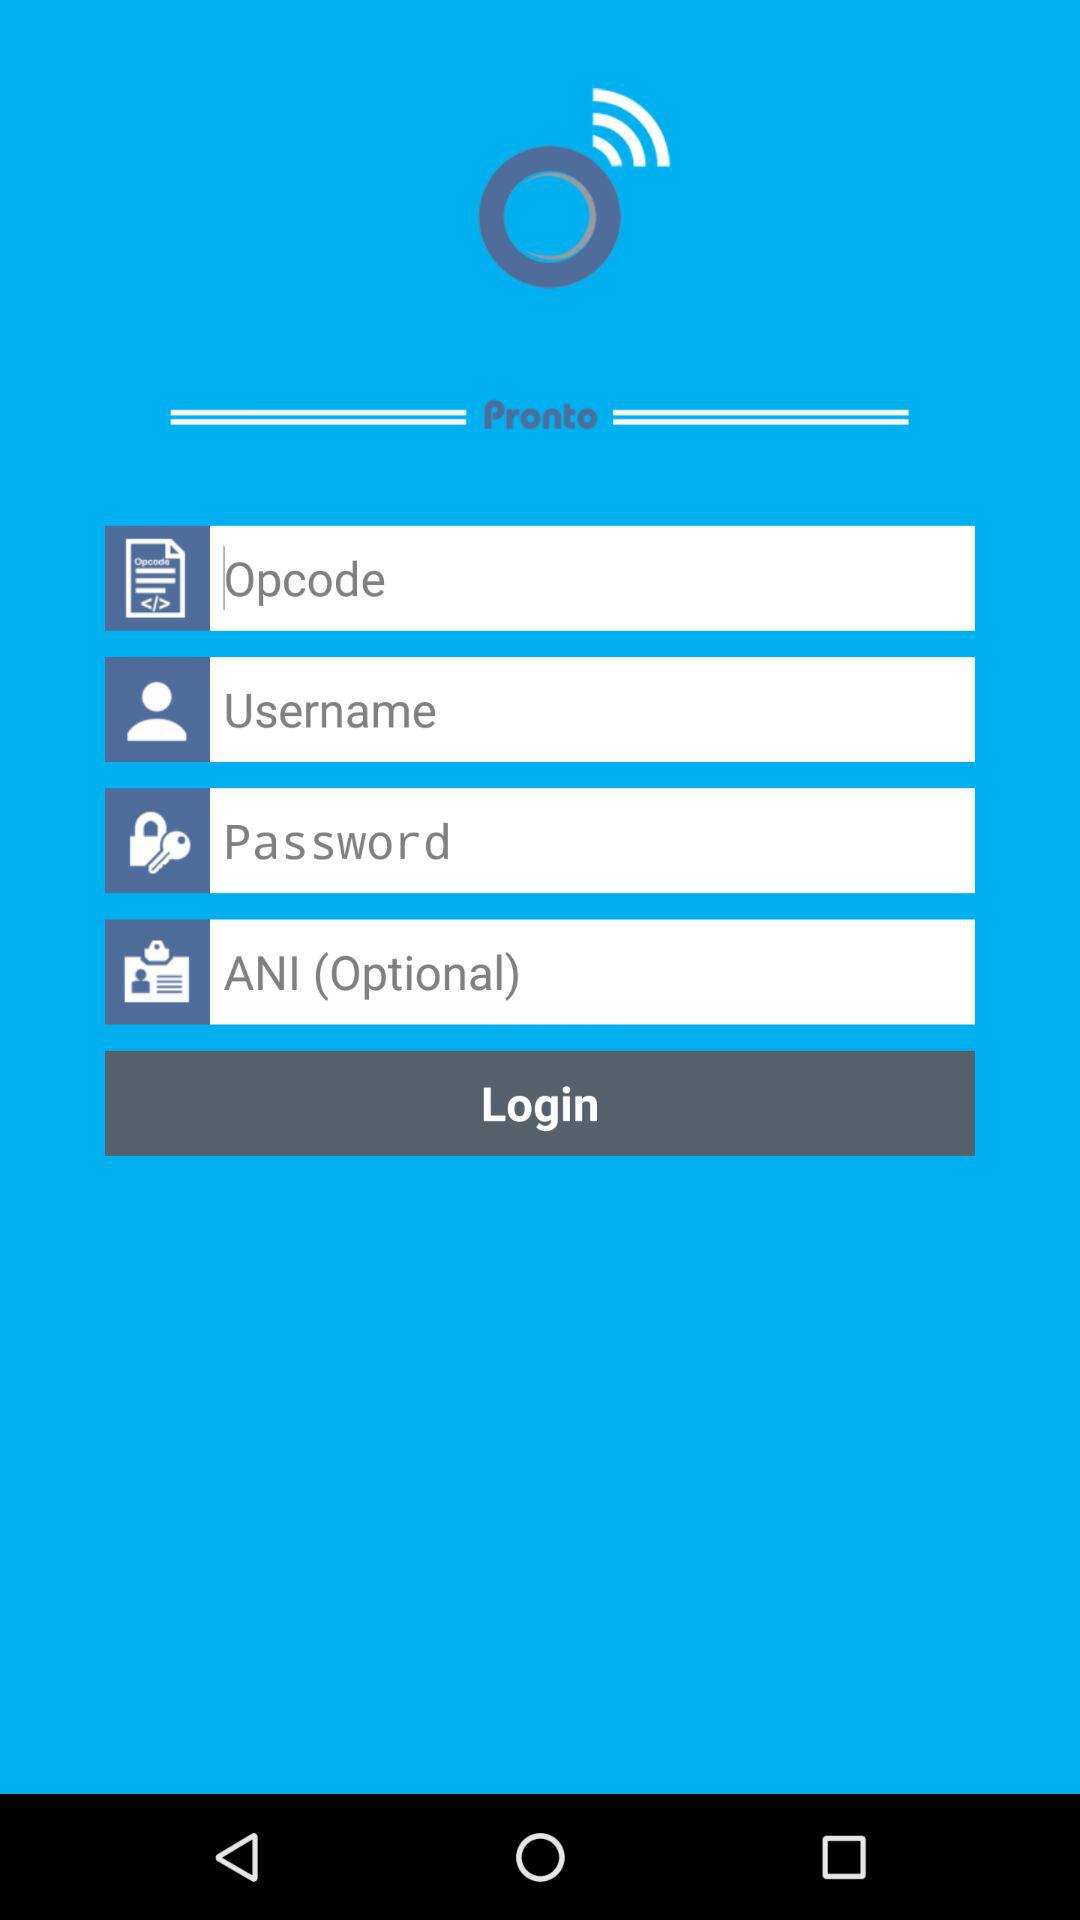What is the name of the application? The name of the application is "Pronto". 